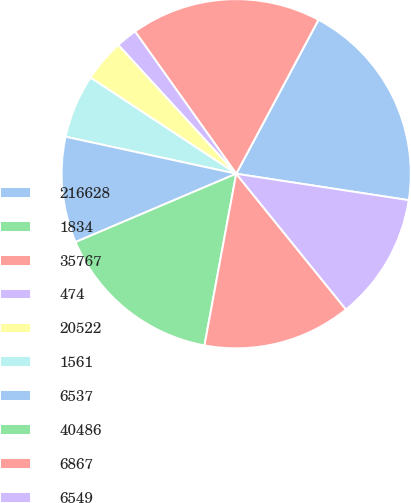Convert chart. <chart><loc_0><loc_0><loc_500><loc_500><pie_chart><fcel>216628<fcel>1834<fcel>35767<fcel>474<fcel>20522<fcel>1561<fcel>6537<fcel>40486<fcel>6867<fcel>6549<nl><fcel>19.61%<fcel>0.0%<fcel>17.65%<fcel>1.96%<fcel>3.92%<fcel>5.88%<fcel>9.8%<fcel>15.69%<fcel>13.73%<fcel>11.76%<nl></chart> 